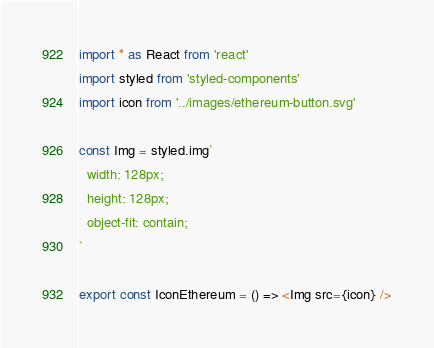Convert code to text. <code><loc_0><loc_0><loc_500><loc_500><_TypeScript_>import * as React from 'react'
import styled from 'styled-components'
import icon from '../images/ethereum-button.svg'

const Img = styled.img`
  width: 128px;
  height: 128px;
  object-fit: contain;
`

export const IconEthereum = () => <Img src={icon} />
</code> 